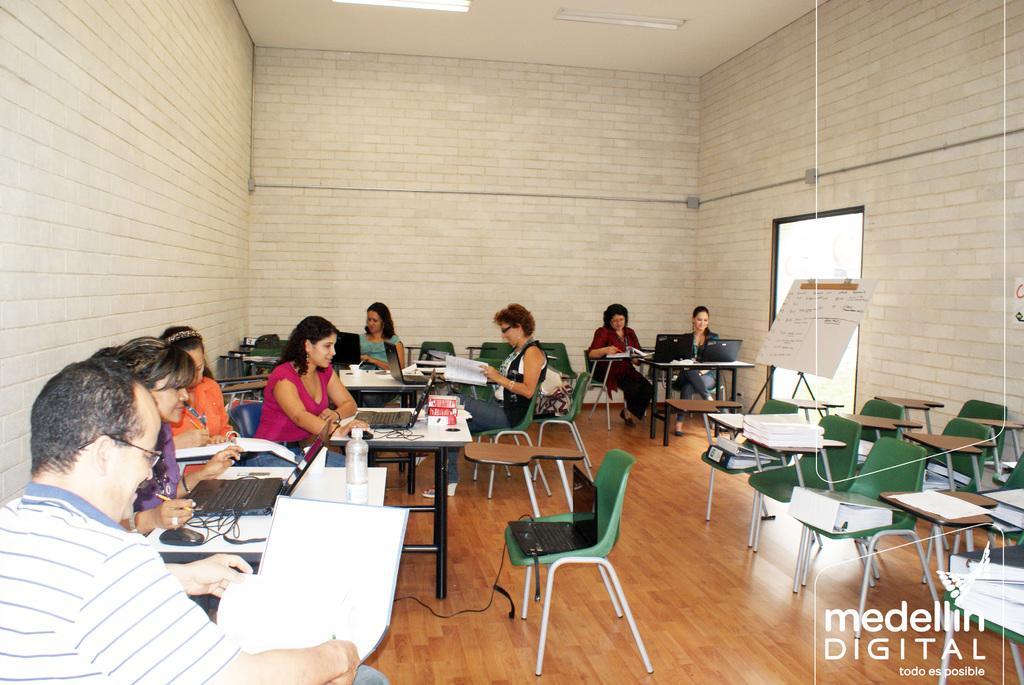Describe this image in one or two sentences. In the image we can see group of persons were sitting on the chair around the table. On table there is a laptop,chart,mouse,pen,book etc. on the right there is a empty chairs. In the background we can see wall. 